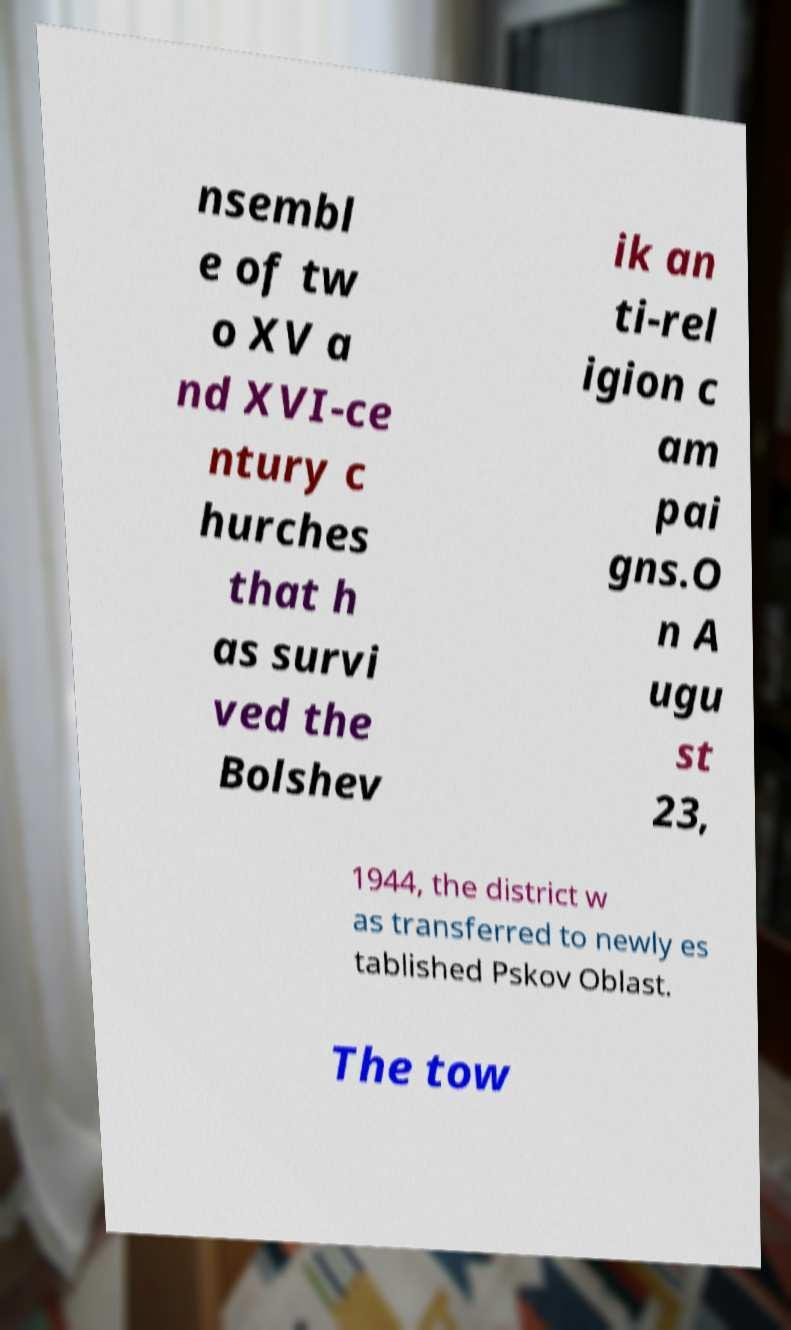Please identify and transcribe the text found in this image. nsembl e of tw o XV a nd XVI-ce ntury c hurches that h as survi ved the Bolshev ik an ti-rel igion c am pai gns.O n A ugu st 23, 1944, the district w as transferred to newly es tablished Pskov Oblast. The tow 